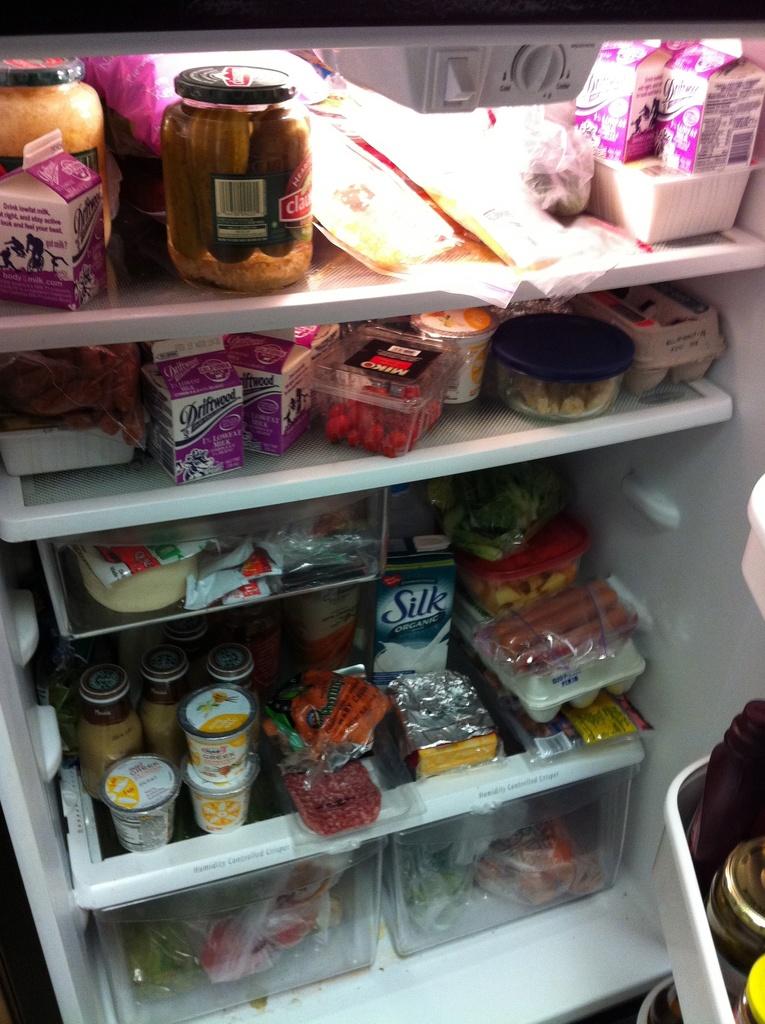What brand of soymilk is on the bottom shelf?
Give a very brief answer. Silk. 